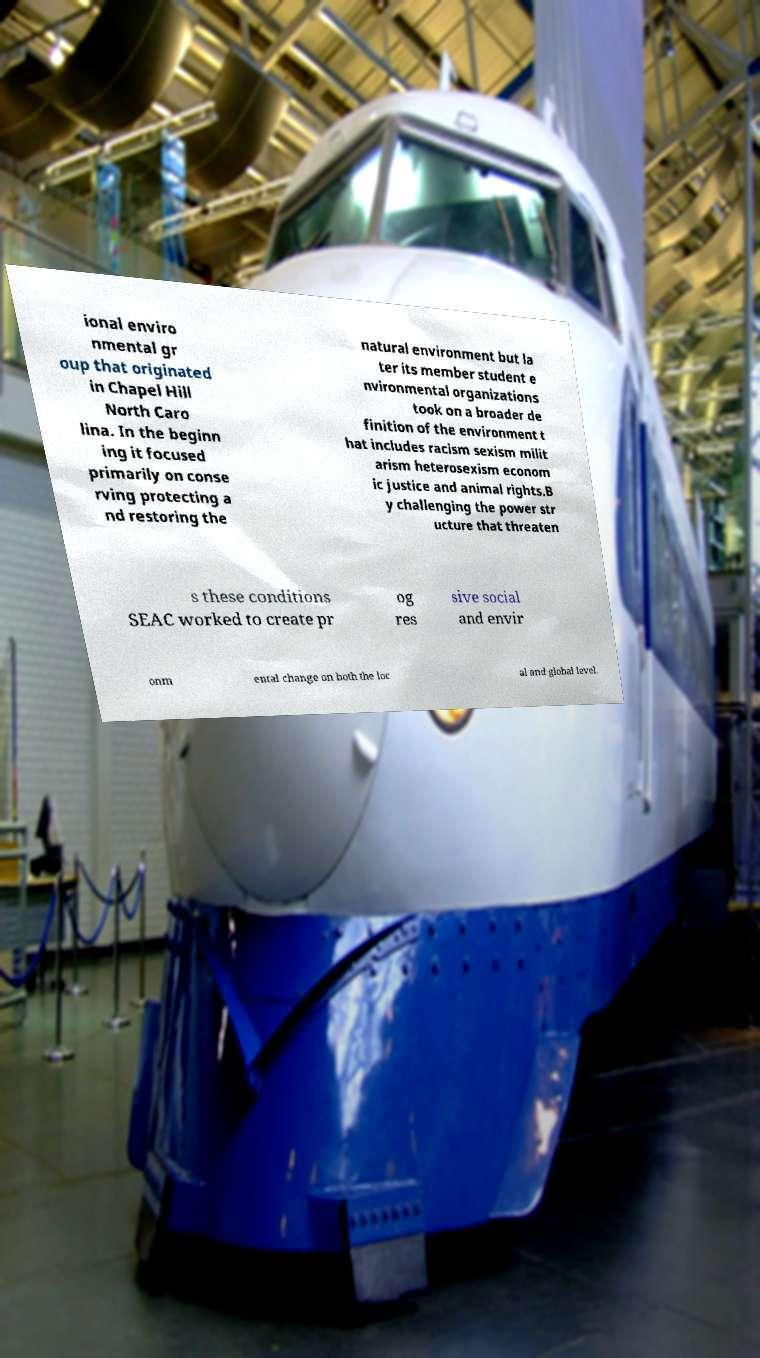Please identify and transcribe the text found in this image. ional enviro nmental gr oup that originated in Chapel Hill North Caro lina. In the beginn ing it focused primarily on conse rving protecting a nd restoring the natural environment but la ter its member student e nvironmental organizations took on a broader de finition of the environment t hat includes racism sexism milit arism heterosexism econom ic justice and animal rights.B y challenging the power str ucture that threaten s these conditions SEAC worked to create pr og res sive social and envir onm ental change on both the loc al and global level. 